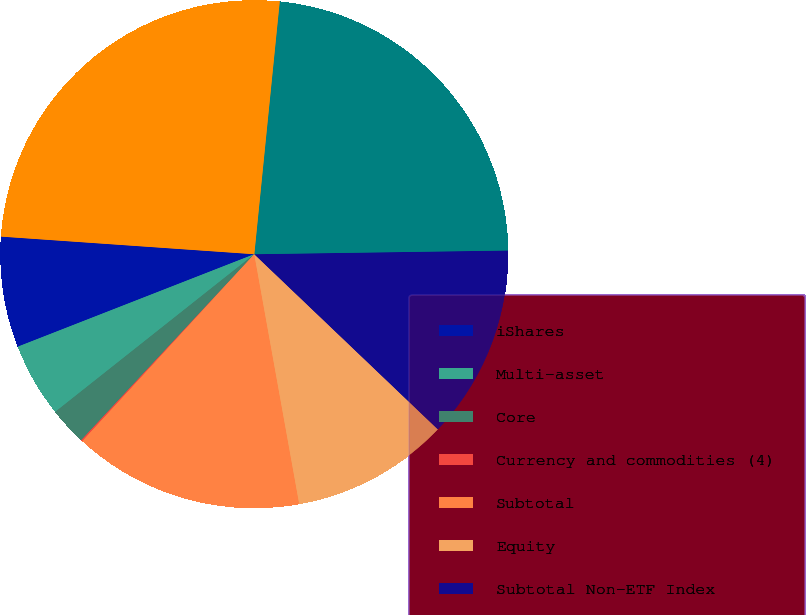<chart> <loc_0><loc_0><loc_500><loc_500><pie_chart><fcel>iShares<fcel>Multi-asset<fcel>Core<fcel>Currency and commodities (4)<fcel>Subtotal<fcel>Equity<fcel>Subtotal Non-ETF Index<fcel>Long-term<fcel>Total<nl><fcel>7.04%<fcel>4.73%<fcel>2.41%<fcel>0.09%<fcel>14.67%<fcel>10.04%<fcel>12.36%<fcel>23.17%<fcel>25.49%<nl></chart> 